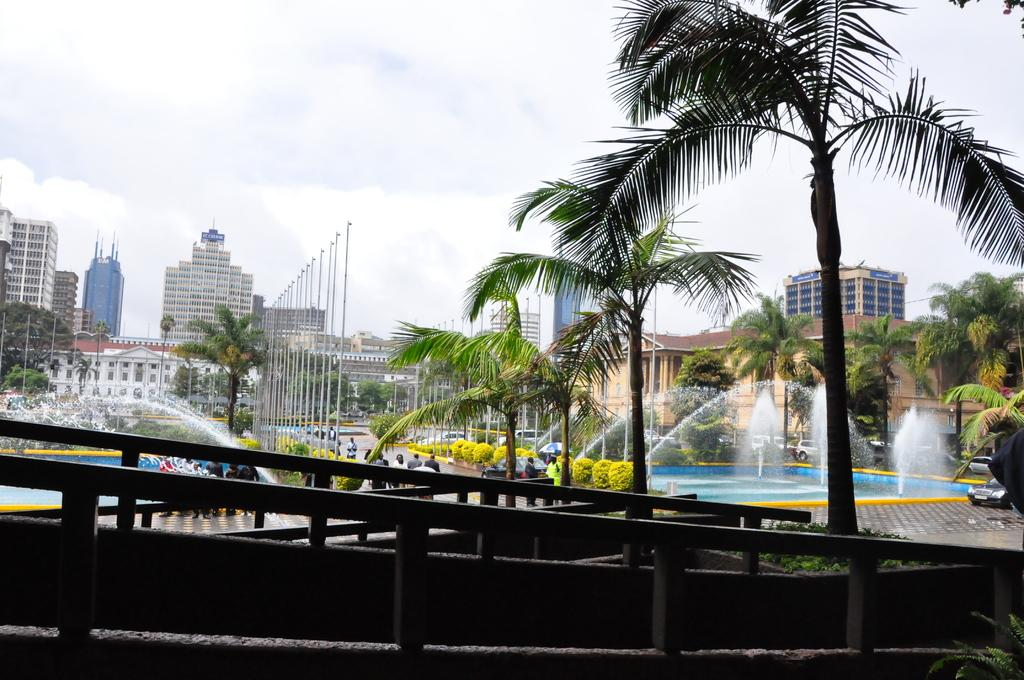What type of objects can be seen in the image? There are iron rods, vehicles, a group of people, trees, plants, water fountains, and poles in the image. What is the purpose of the water fountains? The water fountains are likely for decoration or to provide water for people or plants. What type of structures are visible in the image? There are buildings in the image. What can be seen in the background of the image? The sky is visible in the background of the image. Where is the grandmother sitting in the image? There is no grandmother present in the image. What type of glass object can be seen in the image? There is no glass object present in the image. 